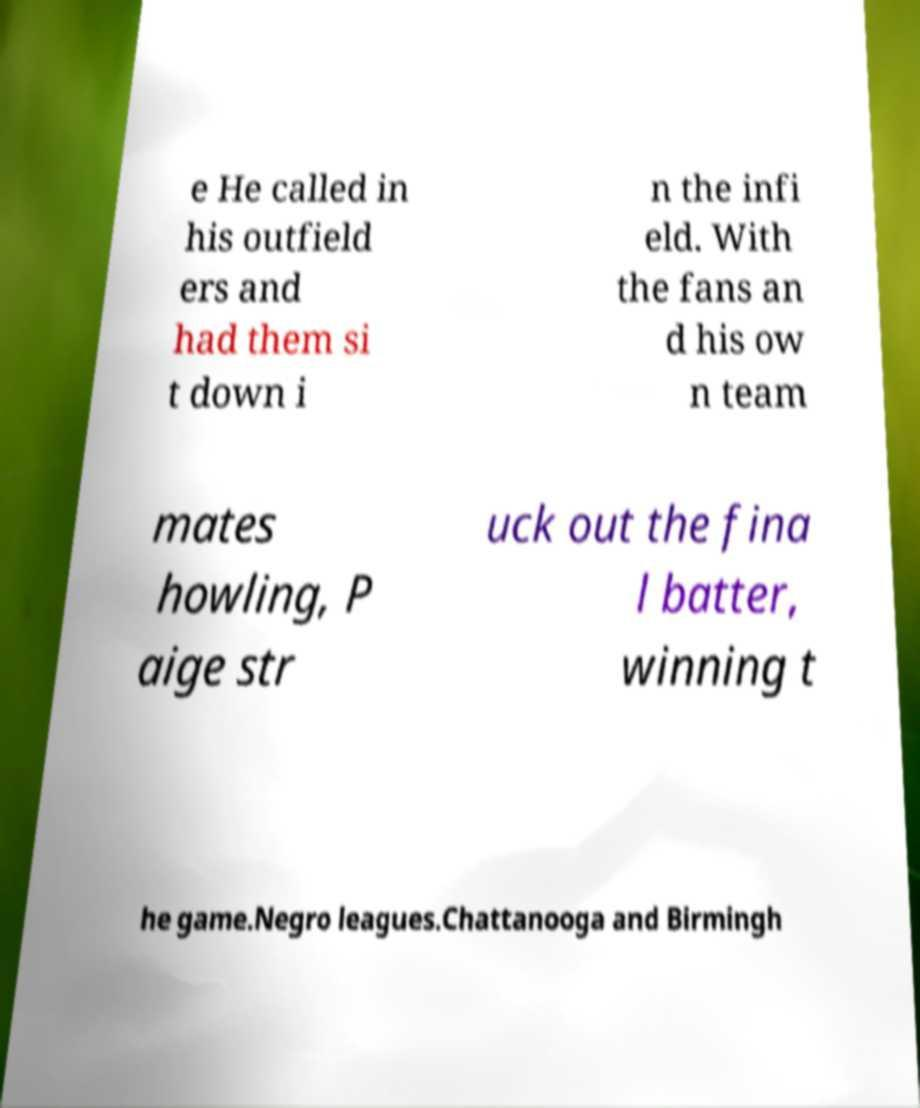Can you accurately transcribe the text from the provided image for me? e He called in his outfield ers and had them si t down i n the infi eld. With the fans an d his ow n team mates howling, P aige str uck out the fina l batter, winning t he game.Negro leagues.Chattanooga and Birmingh 